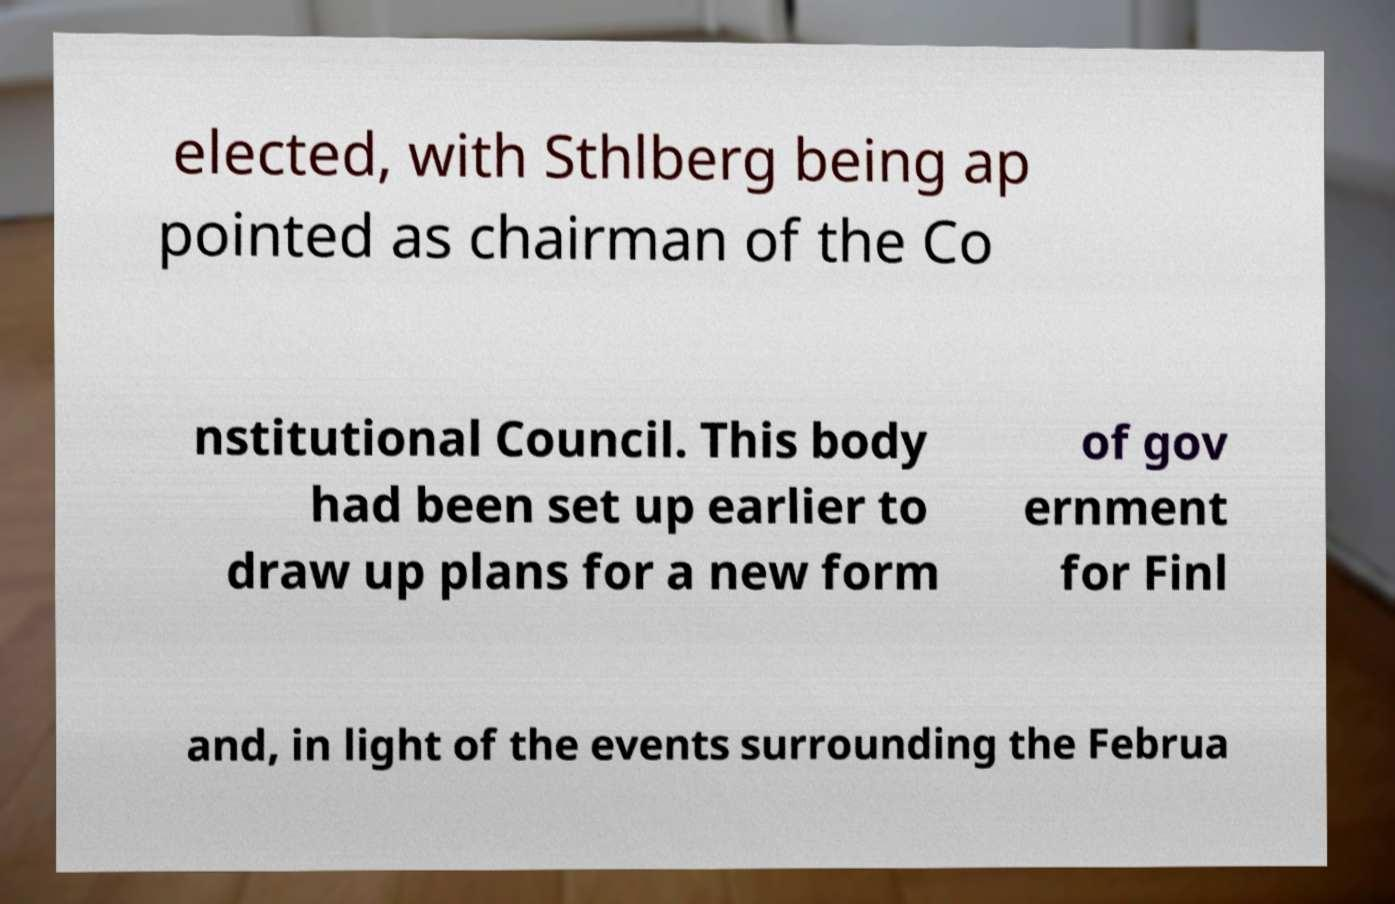Please identify and transcribe the text found in this image. elected, with Sthlberg being ap pointed as chairman of the Co nstitutional Council. This body had been set up earlier to draw up plans for a new form of gov ernment for Finl and, in light of the events surrounding the Februa 